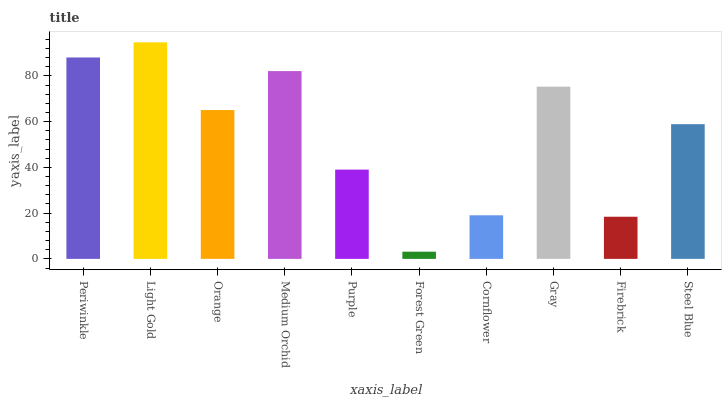Is Forest Green the minimum?
Answer yes or no. Yes. Is Light Gold the maximum?
Answer yes or no. Yes. Is Orange the minimum?
Answer yes or no. No. Is Orange the maximum?
Answer yes or no. No. Is Light Gold greater than Orange?
Answer yes or no. Yes. Is Orange less than Light Gold?
Answer yes or no. Yes. Is Orange greater than Light Gold?
Answer yes or no. No. Is Light Gold less than Orange?
Answer yes or no. No. Is Orange the high median?
Answer yes or no. Yes. Is Steel Blue the low median?
Answer yes or no. Yes. Is Light Gold the high median?
Answer yes or no. No. Is Periwinkle the low median?
Answer yes or no. No. 